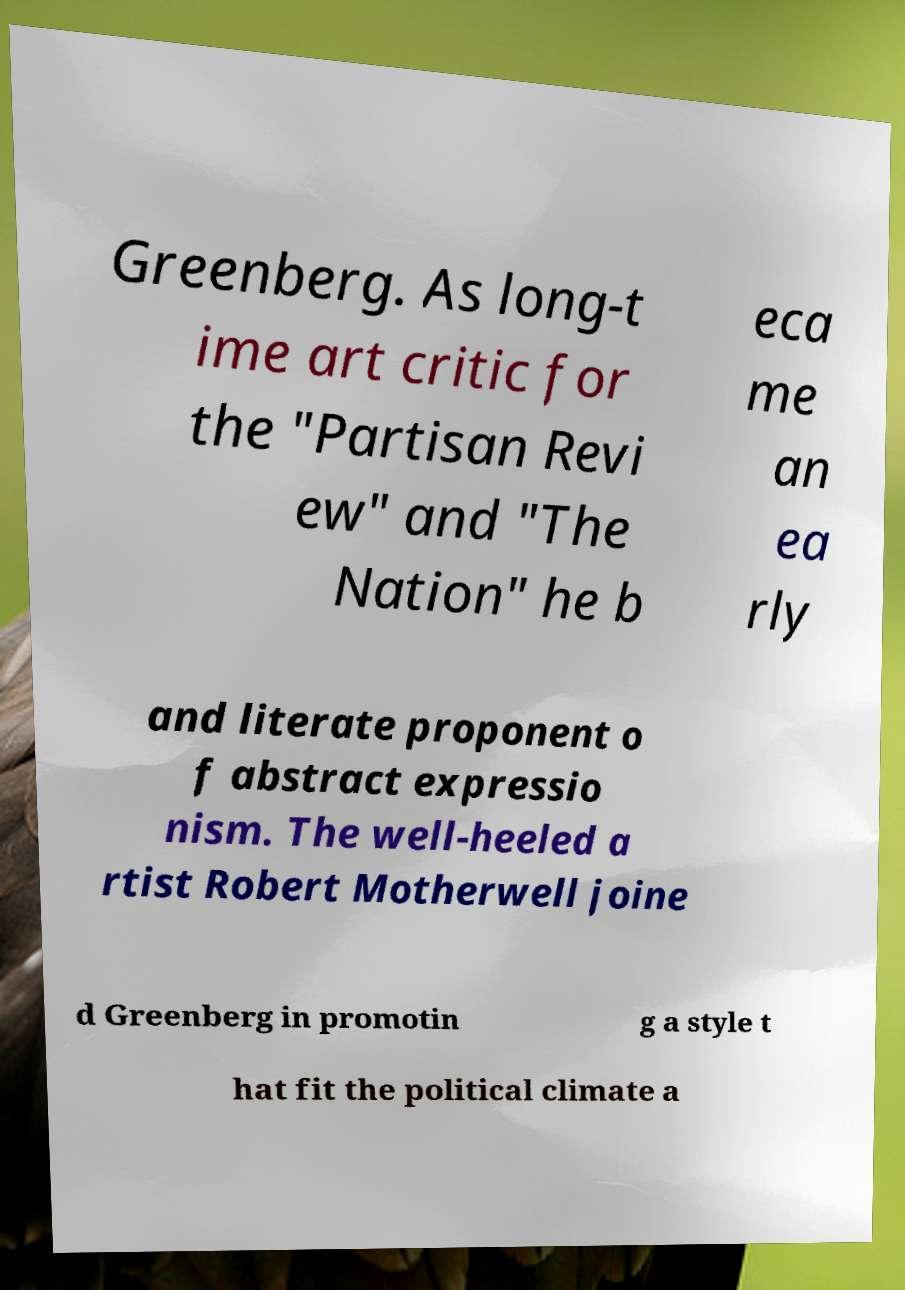Please read and relay the text visible in this image. What does it say? Greenberg. As long-t ime art critic for the "Partisan Revi ew" and "The Nation" he b eca me an ea rly and literate proponent o f abstract expressio nism. The well-heeled a rtist Robert Motherwell joine d Greenberg in promotin g a style t hat fit the political climate a 